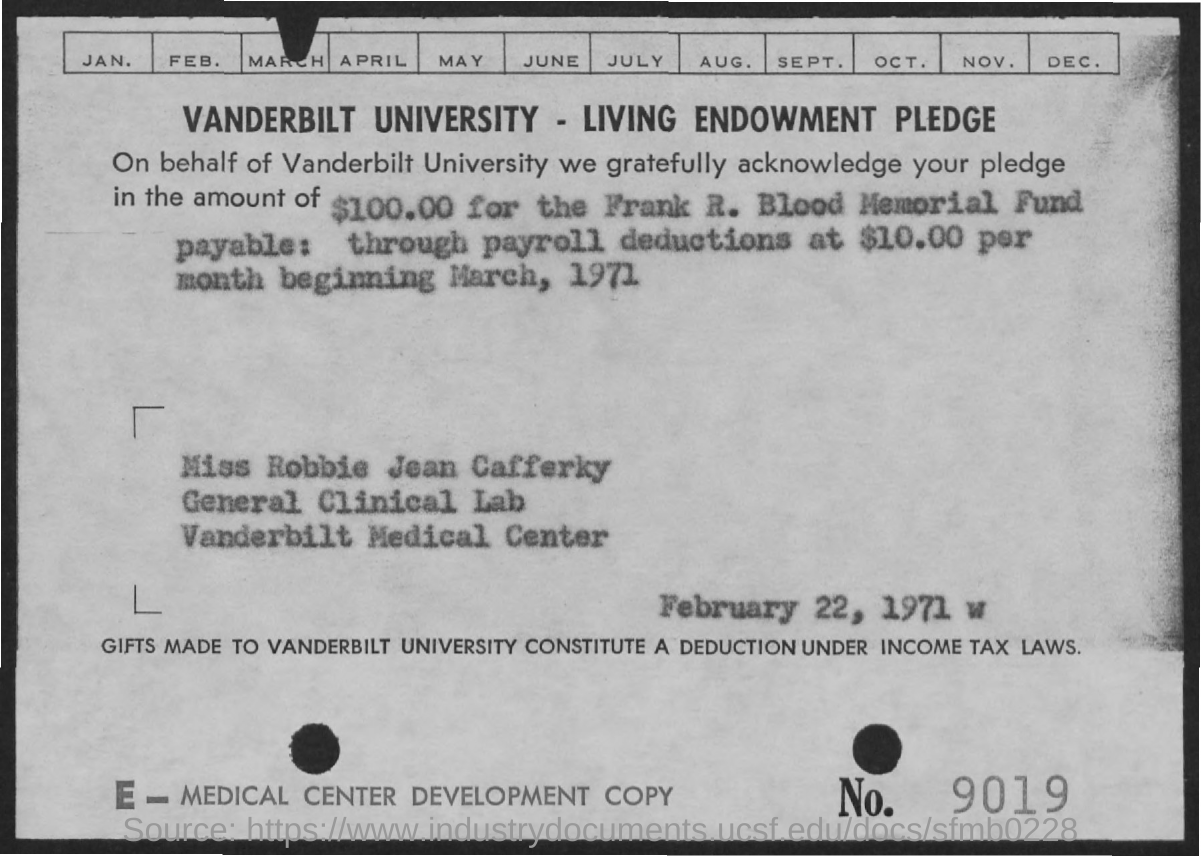Identify some key points in this picture. The date mentioned in the given page is February 22, 1971. 